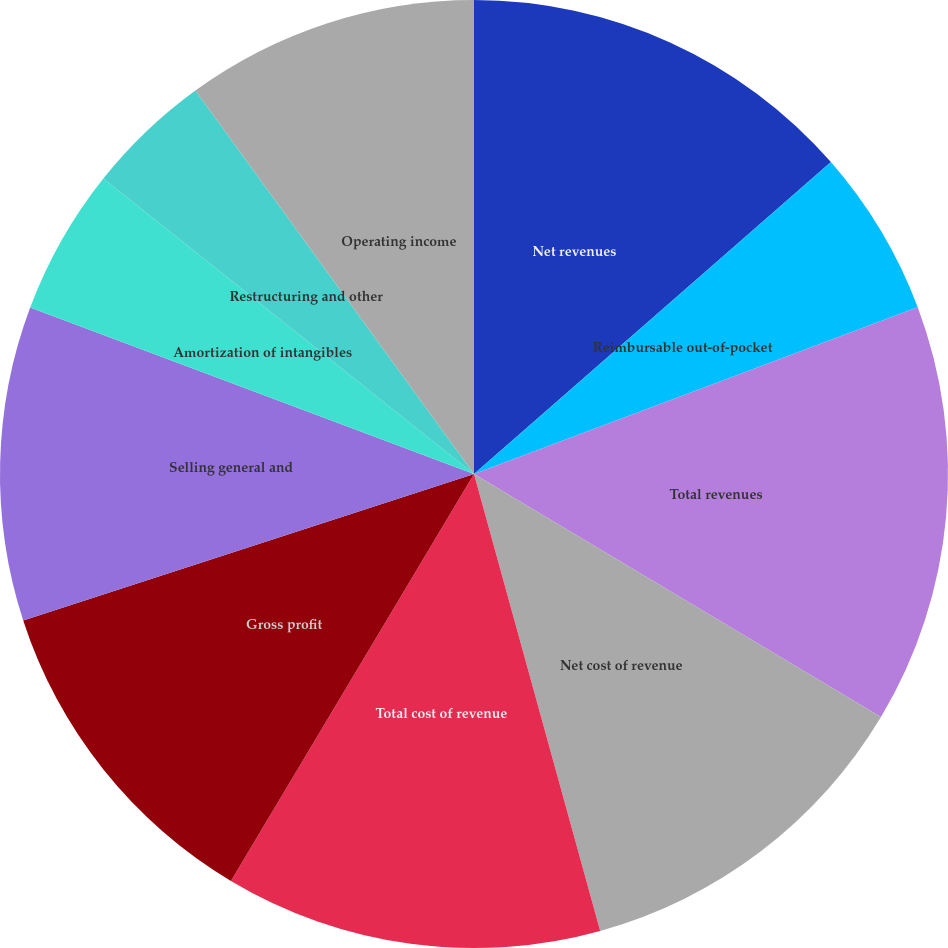<chart> <loc_0><loc_0><loc_500><loc_500><pie_chart><fcel>Net revenues<fcel>Reimbursable out-of-pocket<fcel>Total revenues<fcel>Net cost of revenue<fcel>Total cost of revenue<fcel>Gross profit<fcel>Selling general and<fcel>Amortization of intangibles<fcel>Restructuring and other<fcel>Operating income<nl><fcel>13.57%<fcel>5.71%<fcel>14.29%<fcel>12.14%<fcel>12.86%<fcel>11.43%<fcel>10.71%<fcel>5.0%<fcel>4.29%<fcel>10.0%<nl></chart> 